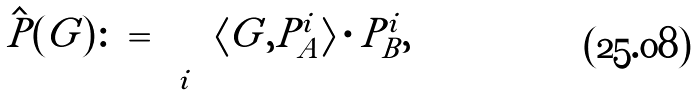<formula> <loc_0><loc_0><loc_500><loc_500>\hat { P } ( G ) \colon = \sum _ { i } \langle G , P _ { A } ^ { i } \rangle \cdot P _ { B } ^ { i } ,</formula> 